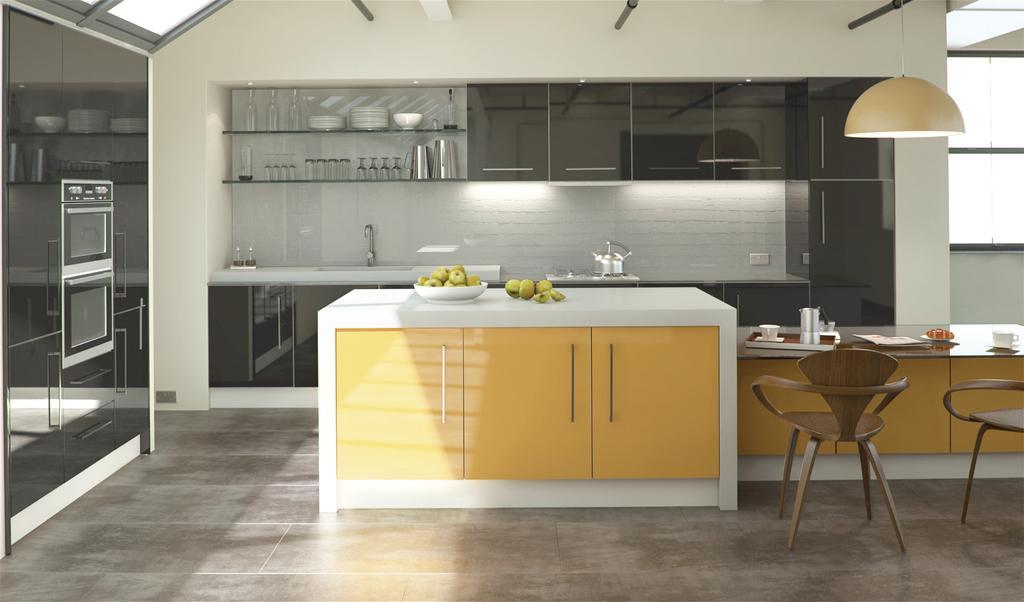How would you summarize this image in a sentence or two? This is an inside view of a room. In the middle of the room I can see a table on which a plate is placed is placed which consists of some fruits in it. Beside this there is another table on which a tray, teacup and few other objects are placed. Beside the table I can see two empty chairs which are placed on the floor. In the background there is a rack in which glasses, plates and bowls are placed and also I can see the cupboards. On the right side there is a window and I can see a light which is hanging to a metal rod. 